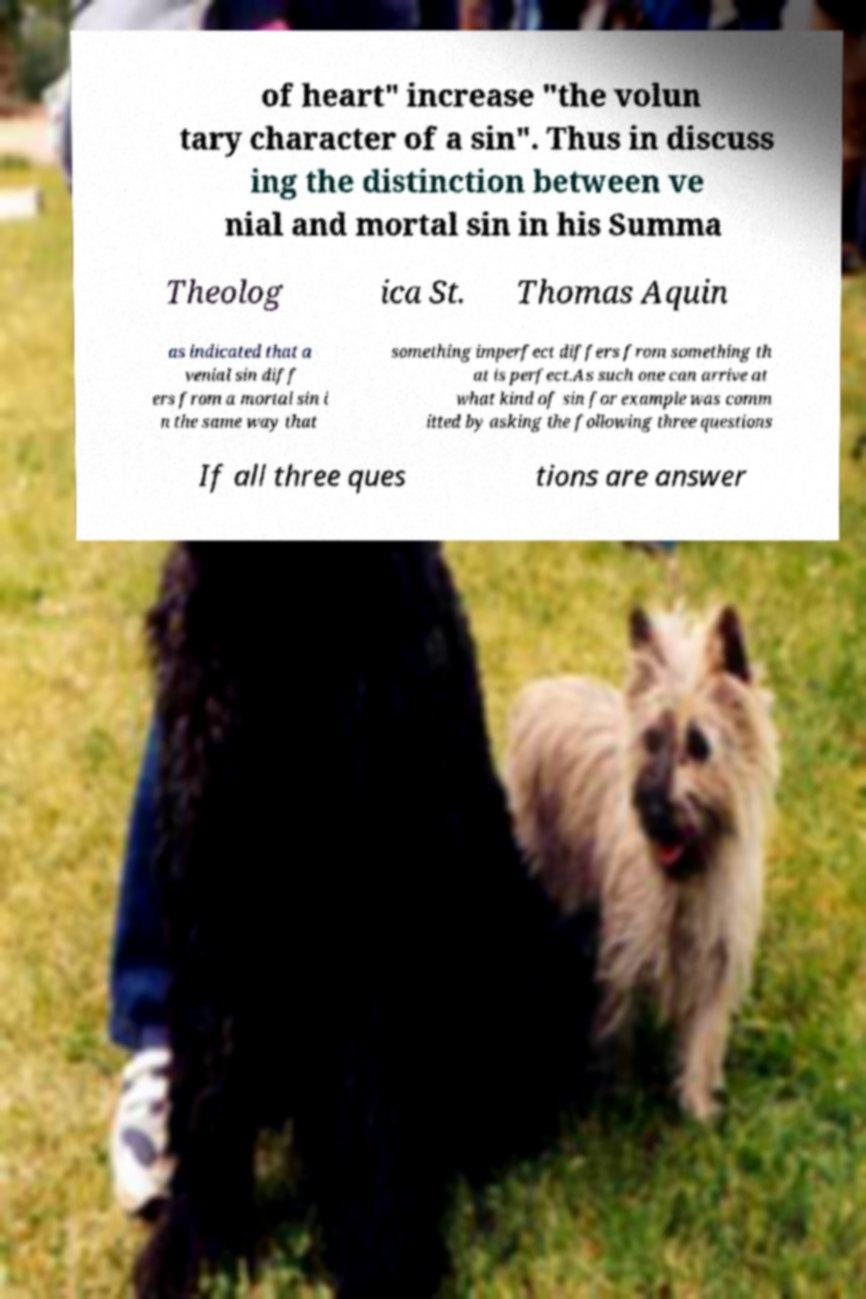Can you accurately transcribe the text from the provided image for me? of heart" increase "the volun tary character of a sin". Thus in discuss ing the distinction between ve nial and mortal sin in his Summa Theolog ica St. Thomas Aquin as indicated that a venial sin diff ers from a mortal sin i n the same way that something imperfect differs from something th at is perfect.As such one can arrive at what kind of sin for example was comm itted by asking the following three questions If all three ques tions are answer 